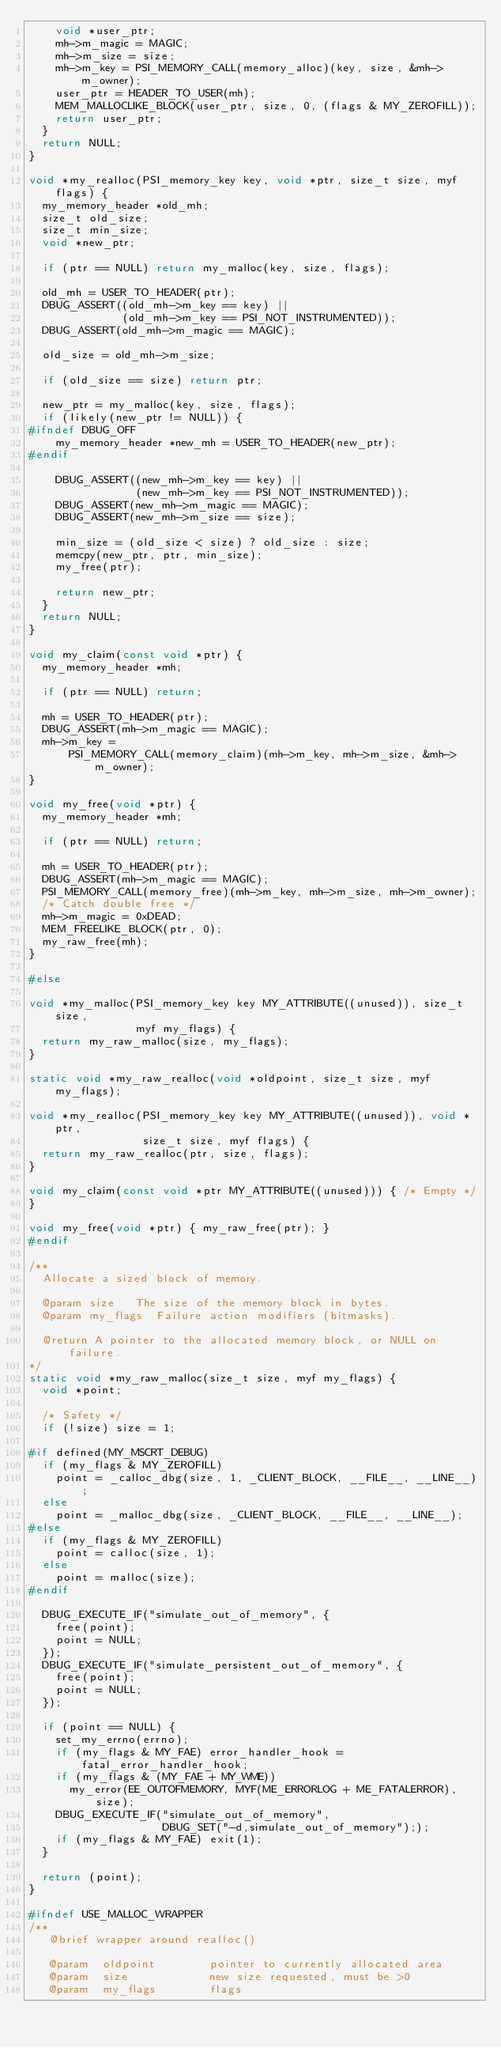Convert code to text. <code><loc_0><loc_0><loc_500><loc_500><_C++_>    void *user_ptr;
    mh->m_magic = MAGIC;
    mh->m_size = size;
    mh->m_key = PSI_MEMORY_CALL(memory_alloc)(key, size, &mh->m_owner);
    user_ptr = HEADER_TO_USER(mh);
    MEM_MALLOCLIKE_BLOCK(user_ptr, size, 0, (flags & MY_ZEROFILL));
    return user_ptr;
  }
  return NULL;
}

void *my_realloc(PSI_memory_key key, void *ptr, size_t size, myf flags) {
  my_memory_header *old_mh;
  size_t old_size;
  size_t min_size;
  void *new_ptr;

  if (ptr == NULL) return my_malloc(key, size, flags);

  old_mh = USER_TO_HEADER(ptr);
  DBUG_ASSERT((old_mh->m_key == key) ||
              (old_mh->m_key == PSI_NOT_INSTRUMENTED));
  DBUG_ASSERT(old_mh->m_magic == MAGIC);

  old_size = old_mh->m_size;

  if (old_size == size) return ptr;

  new_ptr = my_malloc(key, size, flags);
  if (likely(new_ptr != NULL)) {
#ifndef DBUG_OFF
    my_memory_header *new_mh = USER_TO_HEADER(new_ptr);
#endif

    DBUG_ASSERT((new_mh->m_key == key) ||
                (new_mh->m_key == PSI_NOT_INSTRUMENTED));
    DBUG_ASSERT(new_mh->m_magic == MAGIC);
    DBUG_ASSERT(new_mh->m_size == size);

    min_size = (old_size < size) ? old_size : size;
    memcpy(new_ptr, ptr, min_size);
    my_free(ptr);

    return new_ptr;
  }
  return NULL;
}

void my_claim(const void *ptr) {
  my_memory_header *mh;

  if (ptr == NULL) return;

  mh = USER_TO_HEADER(ptr);
  DBUG_ASSERT(mh->m_magic == MAGIC);
  mh->m_key =
      PSI_MEMORY_CALL(memory_claim)(mh->m_key, mh->m_size, &mh->m_owner);
}

void my_free(void *ptr) {
  my_memory_header *mh;

  if (ptr == NULL) return;

  mh = USER_TO_HEADER(ptr);
  DBUG_ASSERT(mh->m_magic == MAGIC);
  PSI_MEMORY_CALL(memory_free)(mh->m_key, mh->m_size, mh->m_owner);
  /* Catch double free */
  mh->m_magic = 0xDEAD;
  MEM_FREELIKE_BLOCK(ptr, 0);
  my_raw_free(mh);
}

#else

void *my_malloc(PSI_memory_key key MY_ATTRIBUTE((unused)), size_t size,
                myf my_flags) {
  return my_raw_malloc(size, my_flags);
}

static void *my_raw_realloc(void *oldpoint, size_t size, myf my_flags);

void *my_realloc(PSI_memory_key key MY_ATTRIBUTE((unused)), void *ptr,
                 size_t size, myf flags) {
  return my_raw_realloc(ptr, size, flags);
}

void my_claim(const void *ptr MY_ATTRIBUTE((unused))) { /* Empty */
}

void my_free(void *ptr) { my_raw_free(ptr); }
#endif

/**
  Allocate a sized block of memory.

  @param size   The size of the memory block in bytes.
  @param my_flags  Failure action modifiers (bitmasks).

  @return A pointer to the allocated memory block, or NULL on failure.
*/
static void *my_raw_malloc(size_t size, myf my_flags) {
  void *point;

  /* Safety */
  if (!size) size = 1;

#if defined(MY_MSCRT_DEBUG)
  if (my_flags & MY_ZEROFILL)
    point = _calloc_dbg(size, 1, _CLIENT_BLOCK, __FILE__, __LINE__);
  else
    point = _malloc_dbg(size, _CLIENT_BLOCK, __FILE__, __LINE__);
#else
  if (my_flags & MY_ZEROFILL)
    point = calloc(size, 1);
  else
    point = malloc(size);
#endif

  DBUG_EXECUTE_IF("simulate_out_of_memory", {
    free(point);
    point = NULL;
  });
  DBUG_EXECUTE_IF("simulate_persistent_out_of_memory", {
    free(point);
    point = NULL;
  });

  if (point == NULL) {
    set_my_errno(errno);
    if (my_flags & MY_FAE) error_handler_hook = fatal_error_handler_hook;
    if (my_flags & (MY_FAE + MY_WME))
      my_error(EE_OUTOFMEMORY, MYF(ME_ERRORLOG + ME_FATALERROR), size);
    DBUG_EXECUTE_IF("simulate_out_of_memory",
                    DBUG_SET("-d,simulate_out_of_memory"););
    if (my_flags & MY_FAE) exit(1);
  }

  return (point);
}

#ifndef USE_MALLOC_WRAPPER
/**
   @brief wrapper around realloc()

   @param  oldpoint        pointer to currently allocated area
   @param  size            new size requested, must be >0
   @param  my_flags        flags
</code> 